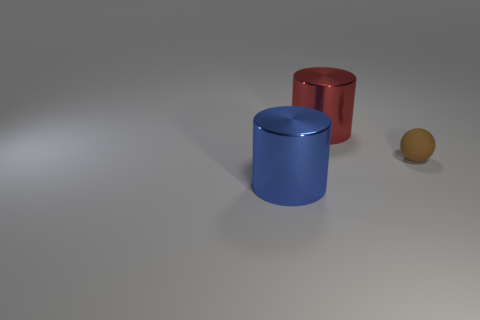Is the large blue cylinder that is to the left of the small rubber sphere made of the same material as the small brown ball?
Give a very brief answer. No. Is the size of the brown matte sphere the same as the blue shiny thing?
Provide a succinct answer. No. How big is the metal thing that is in front of the big cylinder that is behind the brown matte ball?
Provide a succinct answer. Large. There is a thing that is in front of the large red shiny cylinder and left of the brown ball; what size is it?
Make the answer very short. Large. How many other blue cylinders have the same size as the blue cylinder?
Keep it short and to the point. 0. How many metal things are either big red objects or balls?
Provide a succinct answer. 1. What material is the cylinder on the right side of the big cylinder that is in front of the small brown rubber ball?
Offer a very short reply. Metal. How many objects are brown objects or big things behind the blue thing?
Provide a succinct answer. 2. What size is the blue cylinder that is made of the same material as the large red thing?
Keep it short and to the point. Large. How many green objects are either matte spheres or blocks?
Provide a short and direct response. 0. 